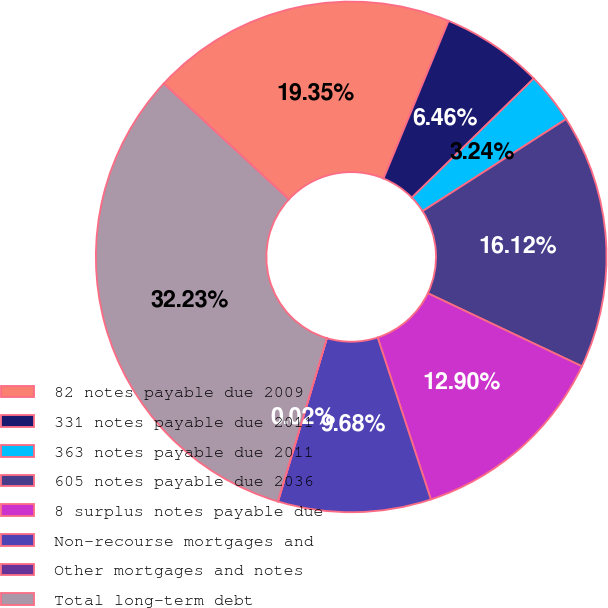<chart> <loc_0><loc_0><loc_500><loc_500><pie_chart><fcel>82 notes payable due 2009<fcel>331 notes payable due 2011<fcel>363 notes payable due 2011<fcel>605 notes payable due 2036<fcel>8 surplus notes payable due<fcel>Non-recourse mortgages and<fcel>Other mortgages and notes<fcel>Total long-term debt<nl><fcel>19.35%<fcel>6.46%<fcel>3.24%<fcel>16.12%<fcel>12.9%<fcel>9.68%<fcel>0.02%<fcel>32.23%<nl></chart> 